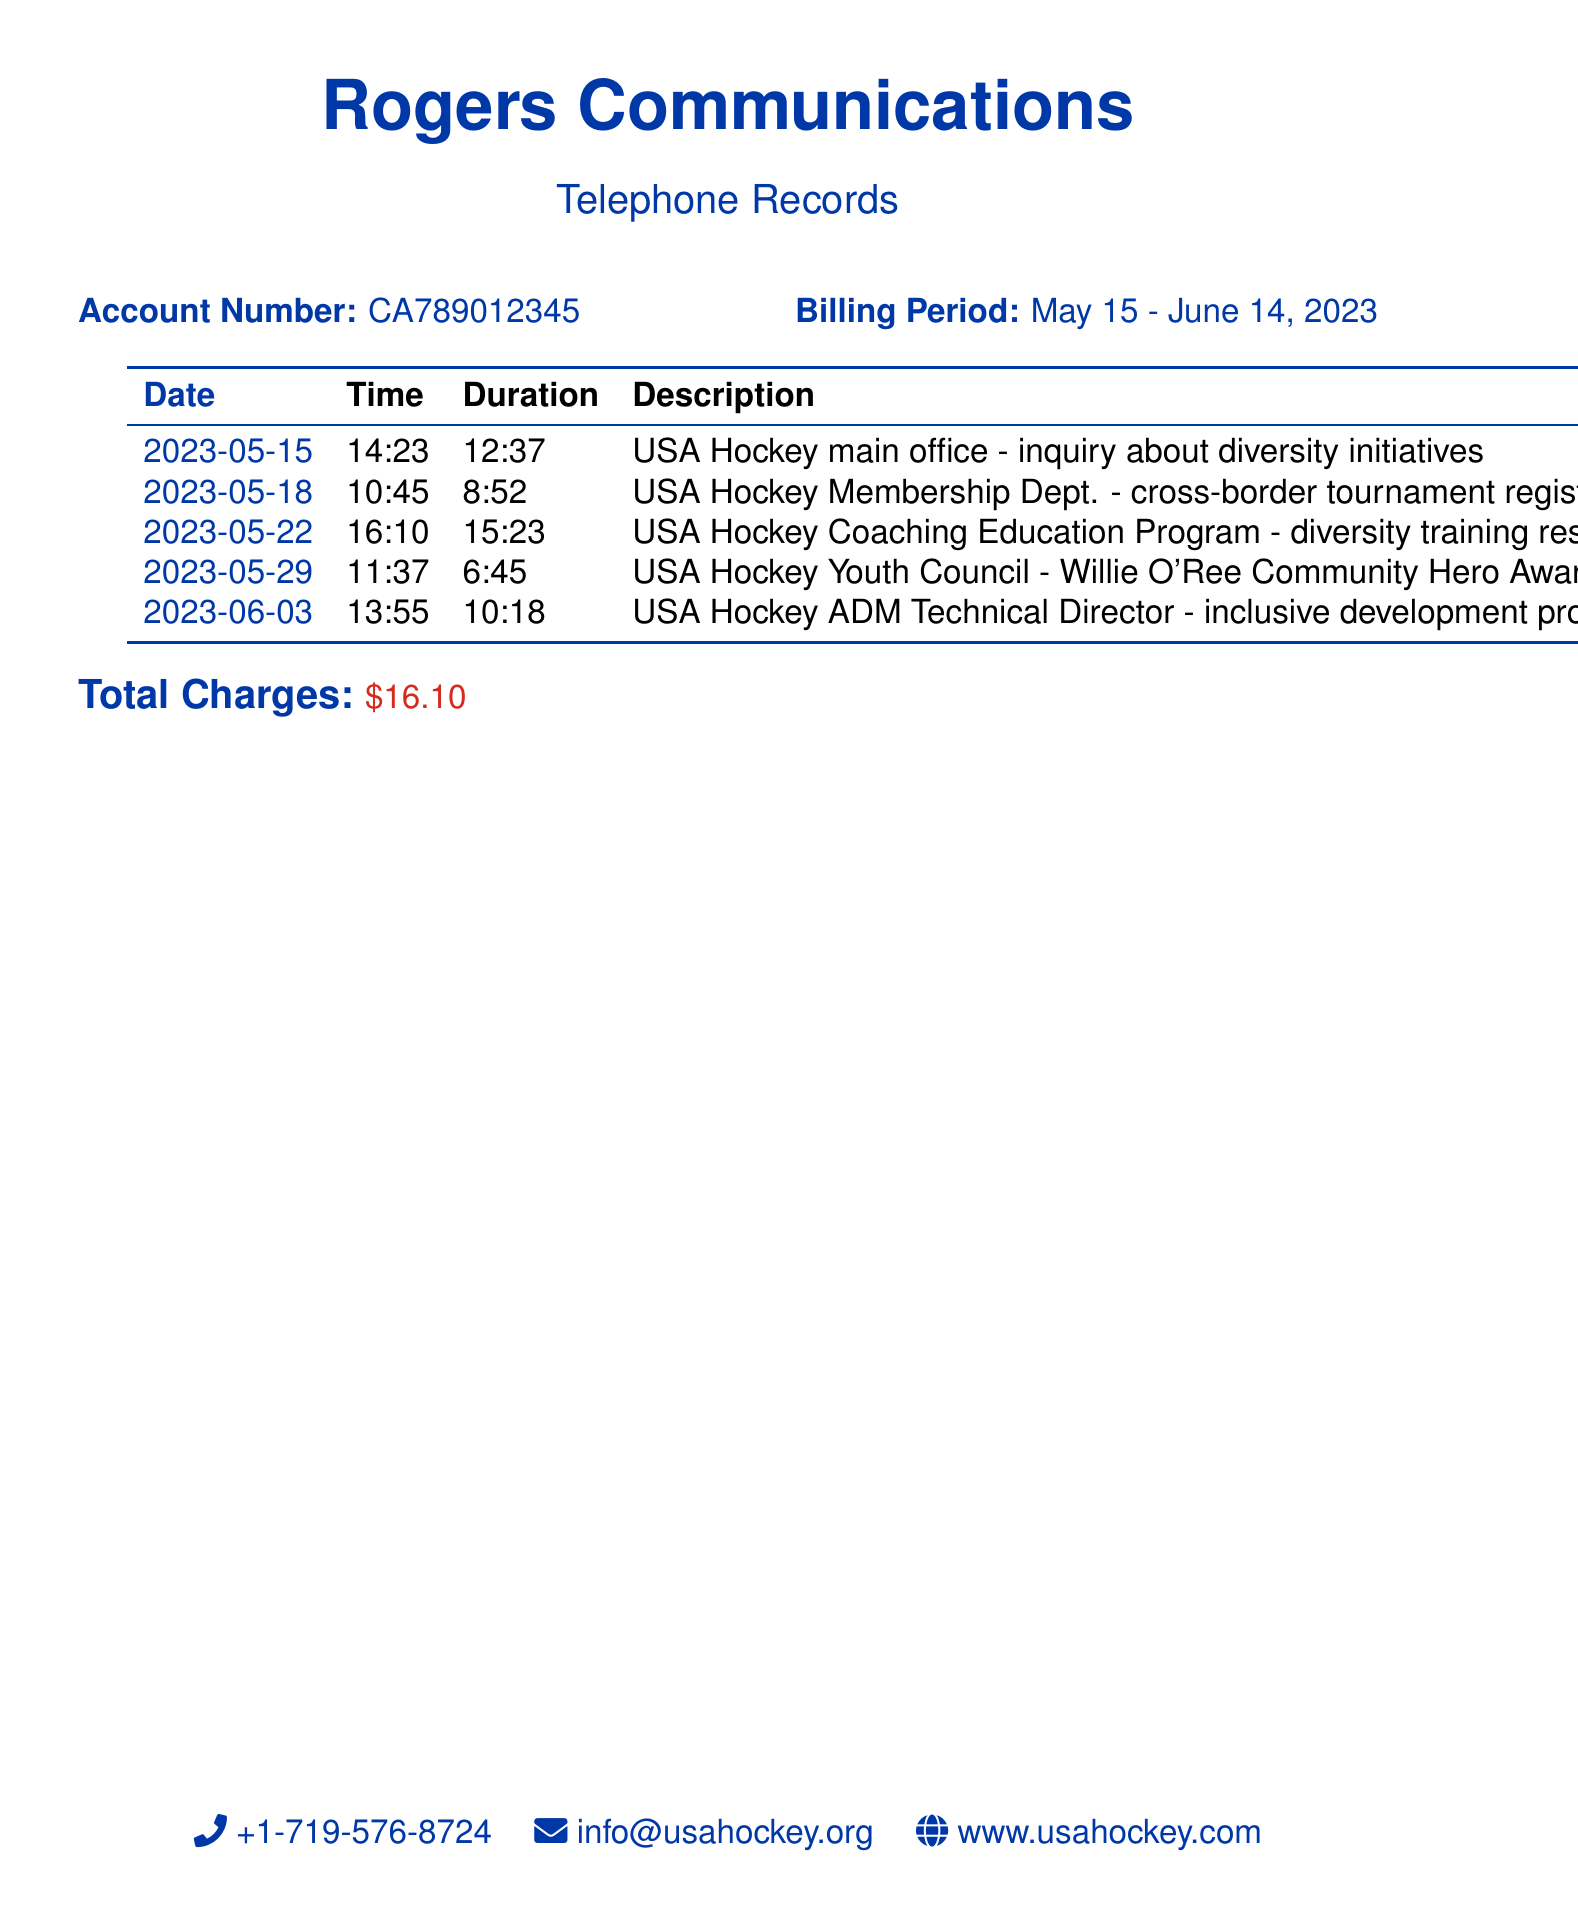What is the account number? The account number is specified in the document, providing a unique identifier for the telephone records.
Answer: CA789012345 What is the billing period? The billing period indicates the time frame for which the charges are calculated, given in the document.
Answer: May 15 - June 14, 2023 How much was charged for the call to inquire about diversity initiatives? The charge for each call is listed in the document alongside the description of the call.
Answer: $3.75 What is the duration of the call to the USA Hockey Youth Council? The duration of each call is mentioned in the document, which provides specific information about the length of the call.
Answer: 6:45 Which department was contacted regarding diversity training resources? The document specifies the department along with the context of the calls made.
Answer: Coaching Education Program How many calls were made in total during the billing period? By counting the entries in the table, we can determine the number of calls made.
Answer: 5 What is the total charge for all the calls? The total charge is calculated by summing all individual call charges listed in the document.
Answer: $16.10 What was the last date a call was made? The last date of a call is given in the document, which helps identify the timeline of calls.
Answer: 2023-06-03 What information was sought from the USA Hockey Youth Council? The document provides specific information concerning the inquiry made during the call.
Answer: Willie O'Ree Community Hero Award information 